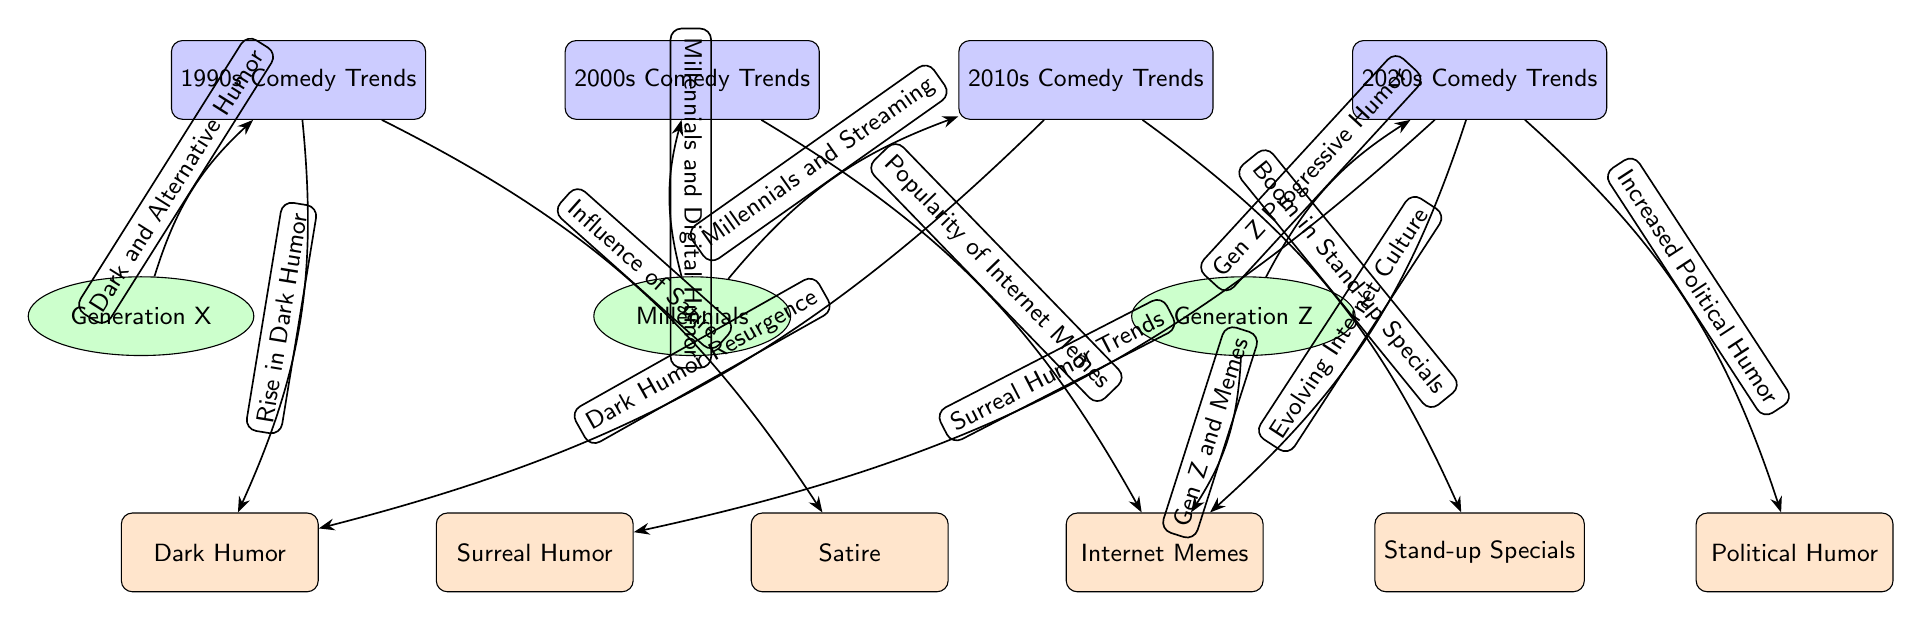What is the main trend associated with the 1990s? The diagram shows that "Dark Humor" and "Influence of Satire" are the key trends related to the 1990s comedy trends. Both trends are directly connected to the 1990s node.
Answer: Dark Humor, Influence of Satire Which generation is linked to the rise of Internet memes? The diagram indicates that "Millennials" are connected to the "Popularity of Internet Memes" trend from the 2000s, denoting their influence on this trend.
Answer: Millennials What decade shows a boom in stand-up specials? According to the diagram, the "2010s Comedy Trends" node has a direct link labeled "Boom in Stand-up Specials." Thus, this indicates that the boom occurred during this decade.
Answer: 2010s How many trends are connected to the 2020 decade? The diagram reveals two trends: "Increased Political Humor" and "Surreal Humor Trends," both connected to the 2020s node. Therefore, two trends are connected to this decade.
Answer: 2 What type of humor is associated with Generation Z? The diagrams show that "Gen Z" is linked to "Gen Z and Memes," indicating that this generation's humor is primarily associated with Internet memes.
Answer: Memes What is the relationship between Millennials and streaming? The diagram explicitly states that there is an edge labeled "Millennials and Streaming" that connects the Millennials generation to the 2010s comedy trends node, signifying their relationship with this form of humor.
Answer: Millennials and Streaming Which humor trend resurged in the 2010s? The 2010s node shows a link labeled "Dark Humor Resurgence," indicating that this trend experienced a revival during this decade.
Answer: Dark Humor Resurgence What type of humor did Generation X primarily enjoy in the 1990s? In the diagram, "Generation X" is associated with "Dark and Alternative Humor," suggesting that this is the primary type of humor they enjoyed in the 1990s.
Answer: Dark and Alternative Humor How does political humor relate to the trends of the 2020s? The diagram connects "Increased Political Humor" directly to the 2020s comedy trends, indicating that this type of humor is a significant aspect of the trends during this decade.
Answer: Increased Political Humor What connection is there between the 2000s and internet memes? The direct edge labeled "Popularity of Internet Memes" illustrates that the 2000s comedy trends are associated with the rise in the popularity of internet memes.
Answer: Popularity of Internet Memes 